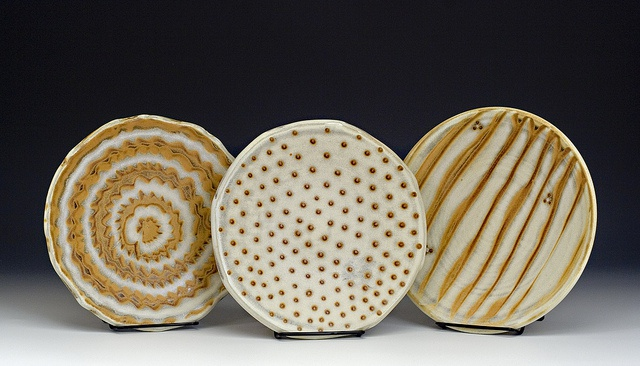Describe the objects in this image and their specific colors. I can see various objects in this image with different colors. 